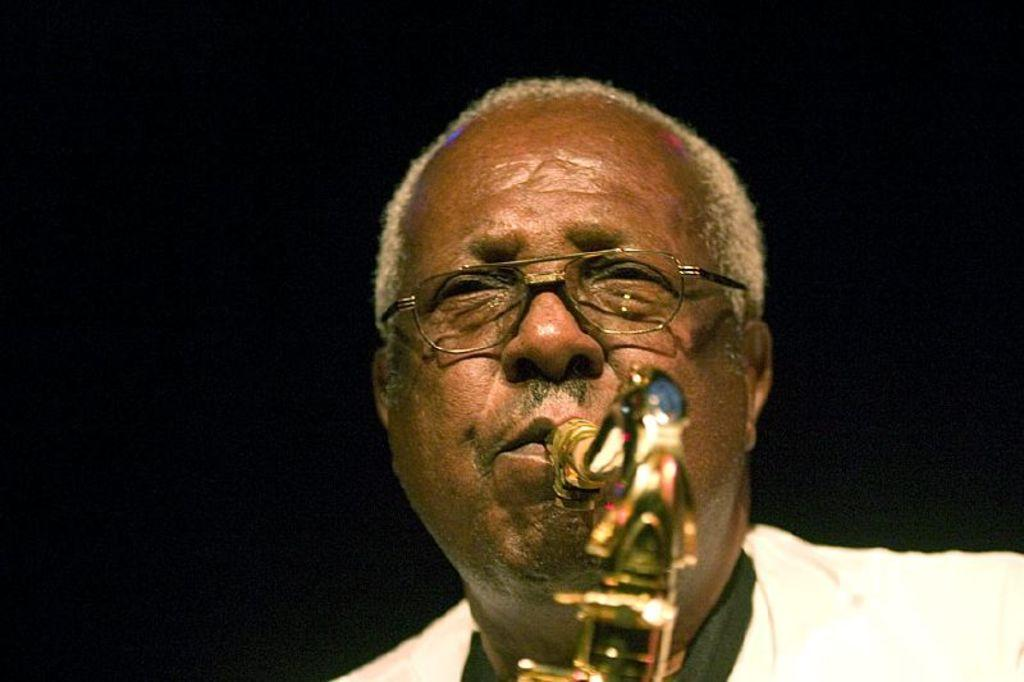What is the main subject of the image? The main subject of the image is a man. What is the man doing in the image? The man is playing a musical instrument with a mouth. Can you describe the man's appearance? The man has white hair. What is the color of the background in the image? The background of the image is dark. How many sisters does the man have in the image? There is no information about the man's sisters in the image. What type of rings can be seen on the man's fingers in the image? There are no rings visible on the man's fingers in the image. 